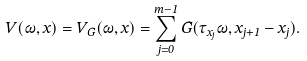<formula> <loc_0><loc_0><loc_500><loc_500>V ( \omega , x ) = V _ { G } ( \omega , x ) = \sum _ { j = 0 } ^ { m - 1 } G ( \tau _ { x _ { j } } \omega , x _ { j + 1 } - x _ { j } ) .</formula> 